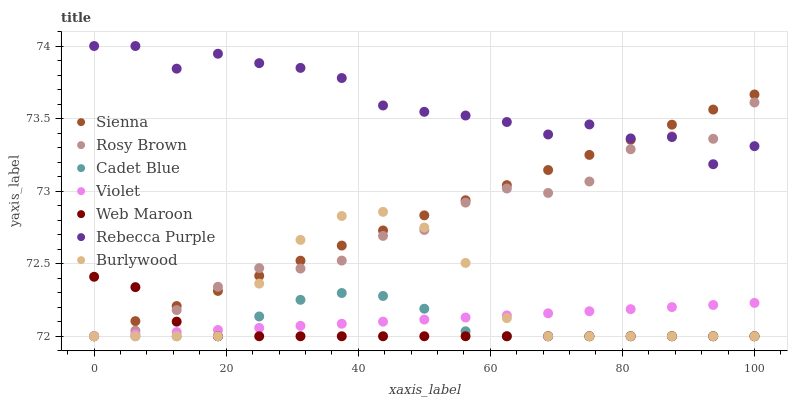Does Web Maroon have the minimum area under the curve?
Answer yes or no. Yes. Does Rebecca Purple have the maximum area under the curve?
Answer yes or no. Yes. Does Burlywood have the minimum area under the curve?
Answer yes or no. No. Does Burlywood have the maximum area under the curve?
Answer yes or no. No. Is Violet the smoothest?
Answer yes or no. Yes. Is Rebecca Purple the roughest?
Answer yes or no. Yes. Is Burlywood the smoothest?
Answer yes or no. No. Is Burlywood the roughest?
Answer yes or no. No. Does Cadet Blue have the lowest value?
Answer yes or no. Yes. Does Rebecca Purple have the lowest value?
Answer yes or no. No. Does Rebecca Purple have the highest value?
Answer yes or no. Yes. Does Burlywood have the highest value?
Answer yes or no. No. Is Violet less than Rebecca Purple?
Answer yes or no. Yes. Is Rebecca Purple greater than Cadet Blue?
Answer yes or no. Yes. Does Rebecca Purple intersect Rosy Brown?
Answer yes or no. Yes. Is Rebecca Purple less than Rosy Brown?
Answer yes or no. No. Is Rebecca Purple greater than Rosy Brown?
Answer yes or no. No. Does Violet intersect Rebecca Purple?
Answer yes or no. No. 